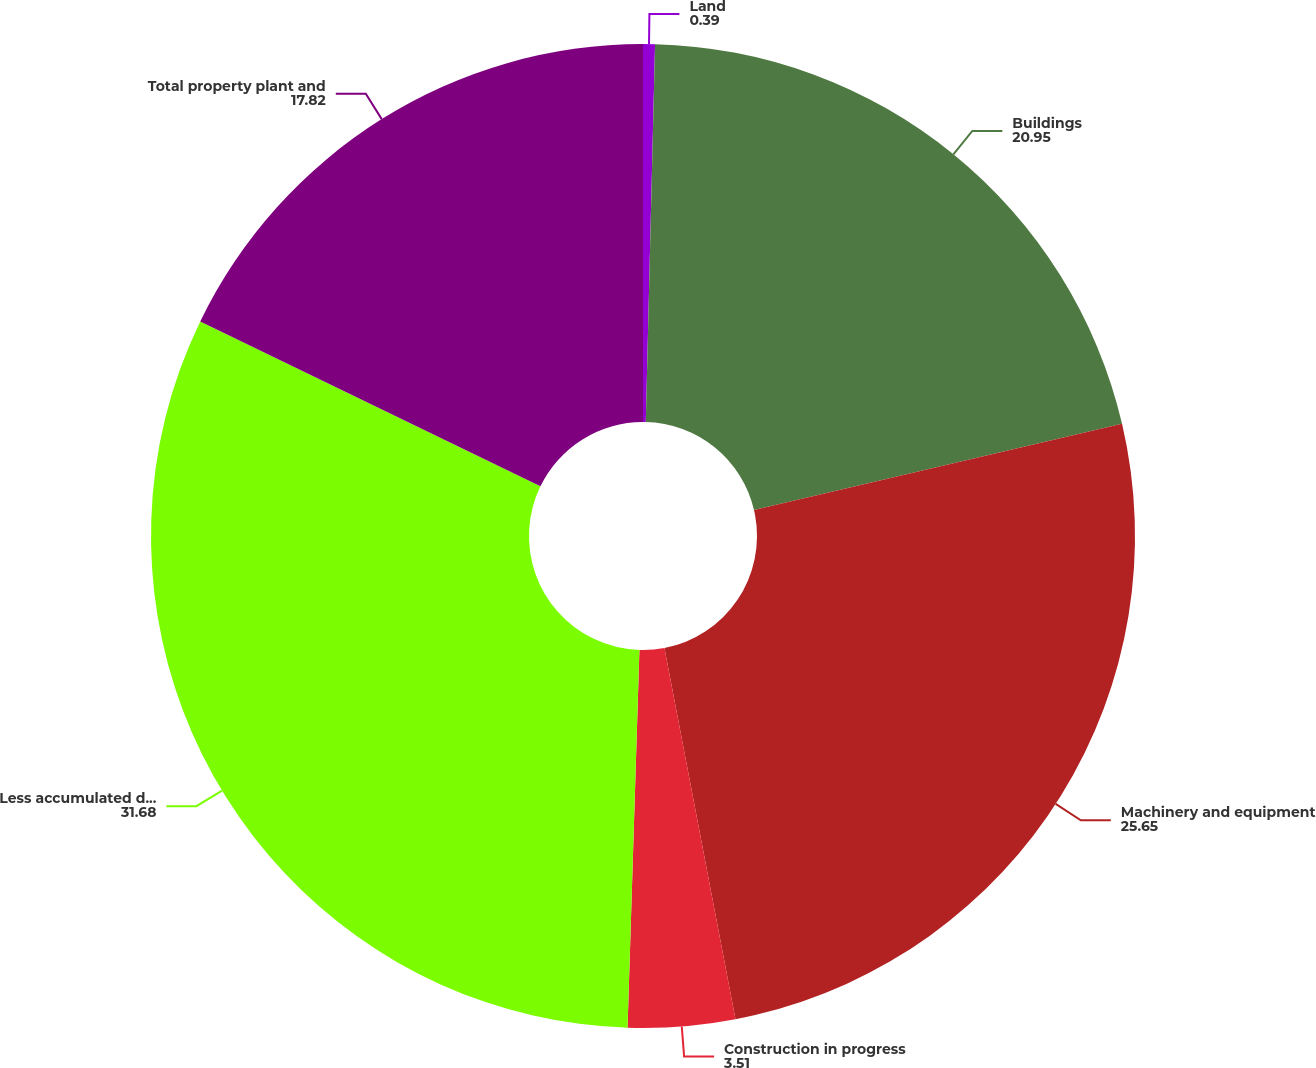<chart> <loc_0><loc_0><loc_500><loc_500><pie_chart><fcel>Land<fcel>Buildings<fcel>Machinery and equipment<fcel>Construction in progress<fcel>Less accumulated depreciation<fcel>Total property plant and<nl><fcel>0.39%<fcel>20.95%<fcel>25.65%<fcel>3.51%<fcel>31.68%<fcel>17.82%<nl></chart> 